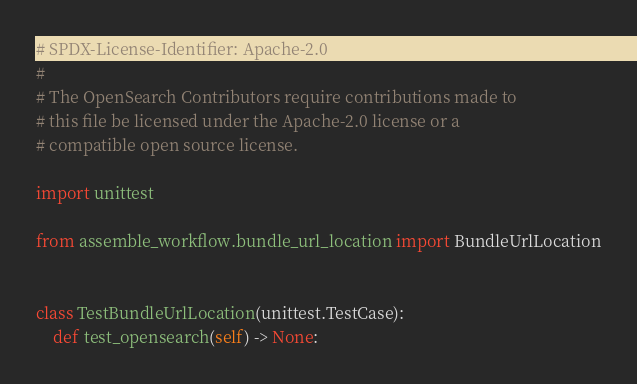Convert code to text. <code><loc_0><loc_0><loc_500><loc_500><_Python_># SPDX-License-Identifier: Apache-2.0
#
# The OpenSearch Contributors require contributions made to
# this file be licensed under the Apache-2.0 license or a
# compatible open source license.

import unittest

from assemble_workflow.bundle_url_location import BundleUrlLocation


class TestBundleUrlLocation(unittest.TestCase):
    def test_opensearch(self) -> None:</code> 